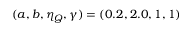Convert formula to latex. <formula><loc_0><loc_0><loc_500><loc_500>( a , b , \eta _ { Q } , \gamma ) = ( 0 . 2 , 2 . 0 , 1 , 1 )</formula> 